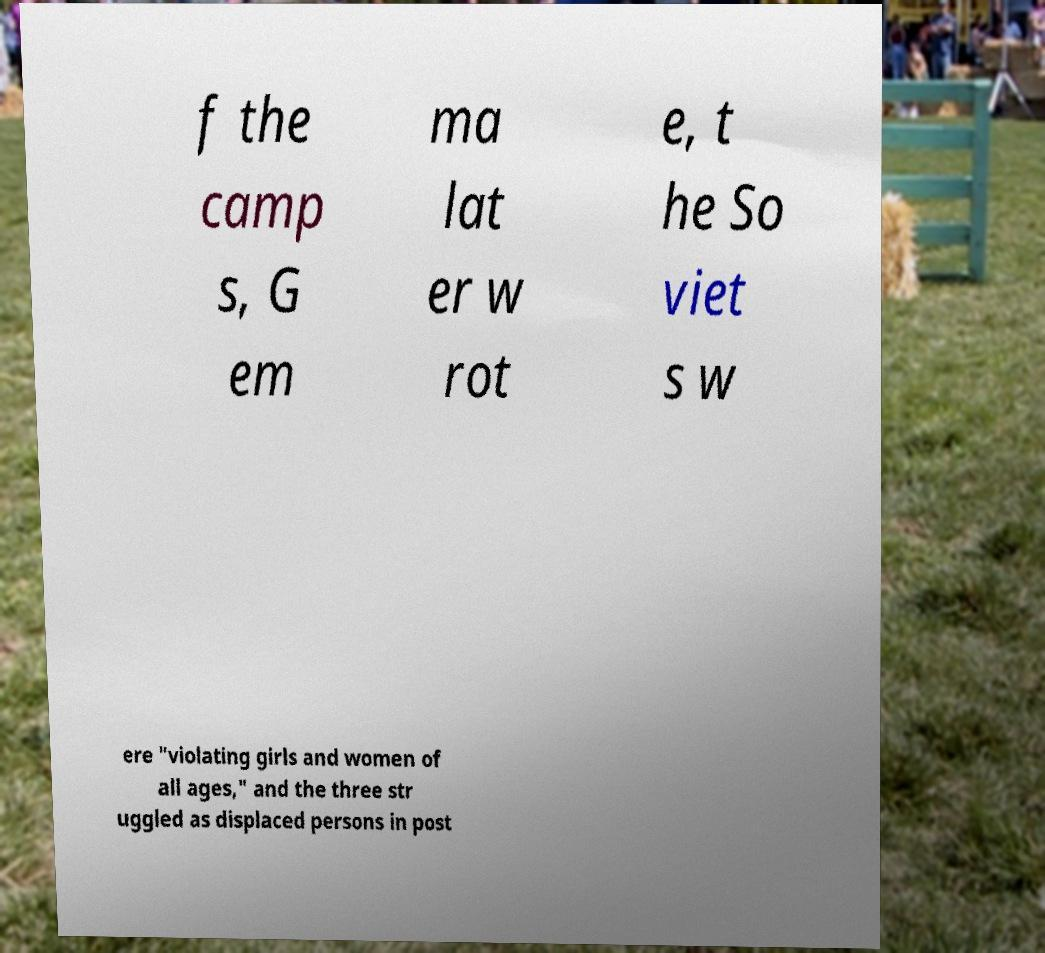What messages or text are displayed in this image? I need them in a readable, typed format. f the camp s, G em ma lat er w rot e, t he So viet s w ere "violating girls and women of all ages," and the three str uggled as displaced persons in post 